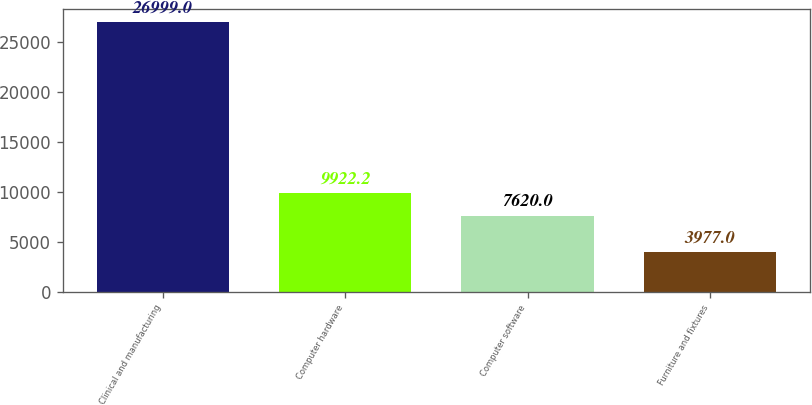Convert chart. <chart><loc_0><loc_0><loc_500><loc_500><bar_chart><fcel>Clinical and manufacturing<fcel>Computer hardware<fcel>Computer software<fcel>Furniture and fixtures<nl><fcel>26999<fcel>9922.2<fcel>7620<fcel>3977<nl></chart> 